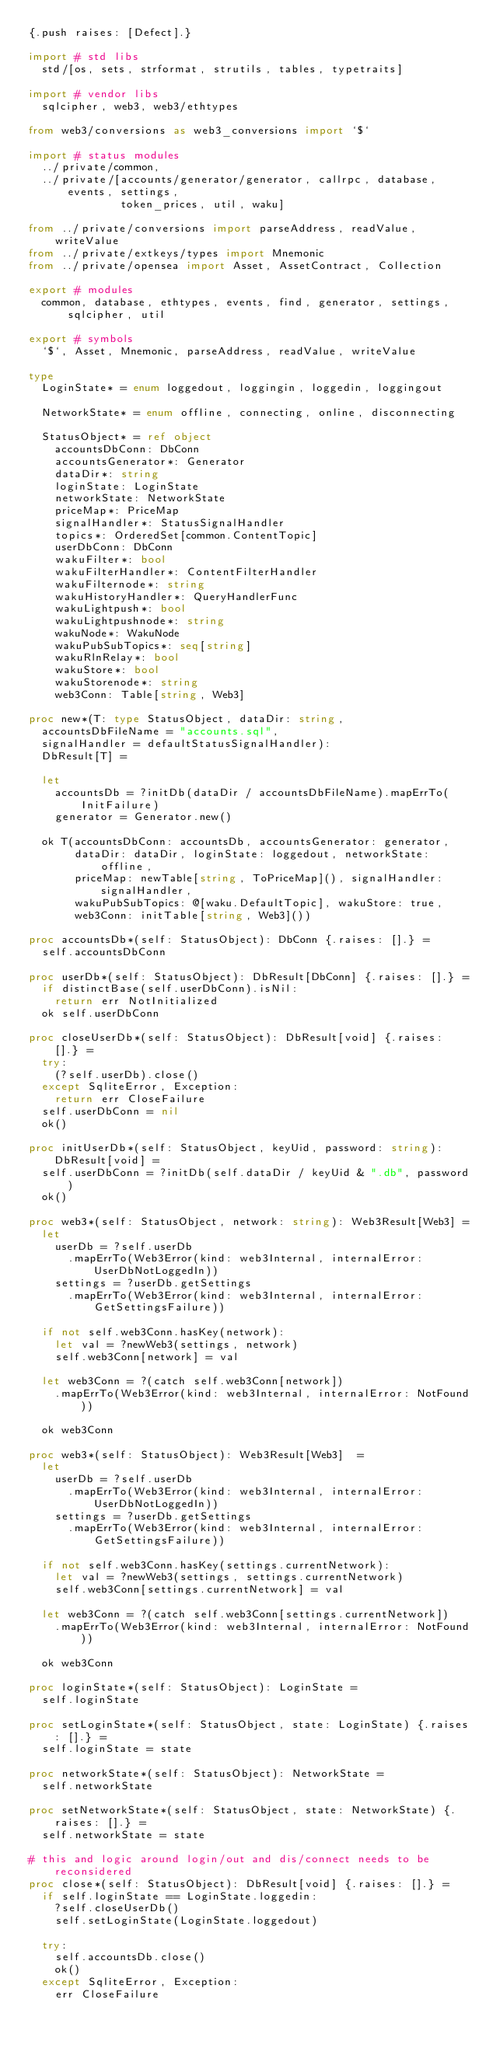Convert code to text. <code><loc_0><loc_0><loc_500><loc_500><_Nim_>{.push raises: [Defect].}

import # std libs
  std/[os, sets, strformat, strutils, tables, typetraits]

import # vendor libs
  sqlcipher, web3, web3/ethtypes

from web3/conversions as web3_conversions import `$`

import # status modules
  ../private/common,
  ../private/[accounts/generator/generator, callrpc, database, events, settings,
              token_prices, util, waku]

from ../private/conversions import parseAddress, readValue, writeValue
from ../private/extkeys/types import Mnemonic
from ../private/opensea import Asset, AssetContract, Collection

export # modules
  common, database, ethtypes, events, find, generator, settings, sqlcipher, util

export # symbols
  `$`, Asset, Mnemonic, parseAddress, readValue, writeValue

type
  LoginState* = enum loggedout, loggingin, loggedin, loggingout

  NetworkState* = enum offline, connecting, online, disconnecting

  StatusObject* = ref object
    accountsDbConn: DbConn
    accountsGenerator*: Generator
    dataDir*: string
    loginState: LoginState
    networkState: NetworkState
    priceMap*: PriceMap
    signalHandler*: StatusSignalHandler
    topics*: OrderedSet[common.ContentTopic]
    userDbConn: DbConn
    wakuFilter*: bool
    wakuFilterHandler*: ContentFilterHandler
    wakuFilternode*: string
    wakuHistoryHandler*: QueryHandlerFunc
    wakuLightpush*: bool
    wakuLightpushnode*: string
    wakuNode*: WakuNode
    wakuPubSubTopics*: seq[string]
    wakuRlnRelay*: bool
    wakuStore*: bool
    wakuStorenode*: string
    web3Conn: Table[string, Web3]

proc new*(T: type StatusObject, dataDir: string,
  accountsDbFileName = "accounts.sql",
  signalHandler = defaultStatusSignalHandler):
  DbResult[T] =

  let
    accountsDb = ?initDb(dataDir / accountsDbFileName).mapErrTo(InitFailure)
    generator = Generator.new()

  ok T(accountsDbConn: accountsDb, accountsGenerator: generator,
       dataDir: dataDir, loginState: loggedout, networkState: offline,
       priceMap: newTable[string, ToPriceMap](), signalHandler: signalHandler,
       wakuPubSubTopics: @[waku.DefaultTopic], wakuStore: true,
       web3Conn: initTable[string, Web3]())

proc accountsDb*(self: StatusObject): DbConn {.raises: [].} =
  self.accountsDbConn

proc userDb*(self: StatusObject): DbResult[DbConn] {.raises: [].} =
  if distinctBase(self.userDbConn).isNil:
    return err NotInitialized
  ok self.userDbConn

proc closeUserDb*(self: StatusObject): DbResult[void] {.raises: [].} =
  try:
    (?self.userDb).close()
  except SqliteError, Exception:
    return err CloseFailure
  self.userDbConn = nil
  ok()

proc initUserDb*(self: StatusObject, keyUid, password: string): DbResult[void] =
  self.userDbConn = ?initDb(self.dataDir / keyUid & ".db", password)
  ok()

proc web3*(self: StatusObject, network: string): Web3Result[Web3] =
  let
    userDb = ?self.userDb
      .mapErrTo(Web3Error(kind: web3Internal, internalError: UserDbNotLoggedIn))
    settings = ?userDb.getSettings
      .mapErrTo(Web3Error(kind: web3Internal, internalError: GetSettingsFailure))

  if not self.web3Conn.hasKey(network):
    let val = ?newWeb3(settings, network)
    self.web3Conn[network] = val

  let web3Conn = ?(catch self.web3Conn[network])
    .mapErrTo(Web3Error(kind: web3Internal, internalError: NotFound))

  ok web3Conn

proc web3*(self: StatusObject): Web3Result[Web3]  =
  let
    userDb = ?self.userDb
      .mapErrTo(Web3Error(kind: web3Internal, internalError: UserDbNotLoggedIn))
    settings = ?userDb.getSettings
      .mapErrTo(Web3Error(kind: web3Internal, internalError: GetSettingsFailure))

  if not self.web3Conn.hasKey(settings.currentNetwork):
    let val = ?newWeb3(settings, settings.currentNetwork)
    self.web3Conn[settings.currentNetwork] = val

  let web3Conn = ?(catch self.web3Conn[settings.currentNetwork])
    .mapErrTo(Web3Error(kind: web3Internal, internalError: NotFound))

  ok web3Conn

proc loginState*(self: StatusObject): LoginState =
  self.loginState

proc setLoginState*(self: StatusObject, state: LoginState) {.raises: [].} =
  self.loginState = state

proc networkState*(self: StatusObject): NetworkState =
  self.networkState

proc setNetworkState*(self: StatusObject, state: NetworkState) {.raises: [].} =
  self.networkState = state

# this and logic around login/out and dis/connect needs to be reconsidered
proc close*(self: StatusObject): DbResult[void] {.raises: [].} =
  if self.loginState == LoginState.loggedin:
    ?self.closeUserDb()
    self.setLoginState(LoginState.loggedout)

  try:
    self.accountsDb.close()
    ok()
  except SqliteError, Exception:
    err CloseFailure
</code> 